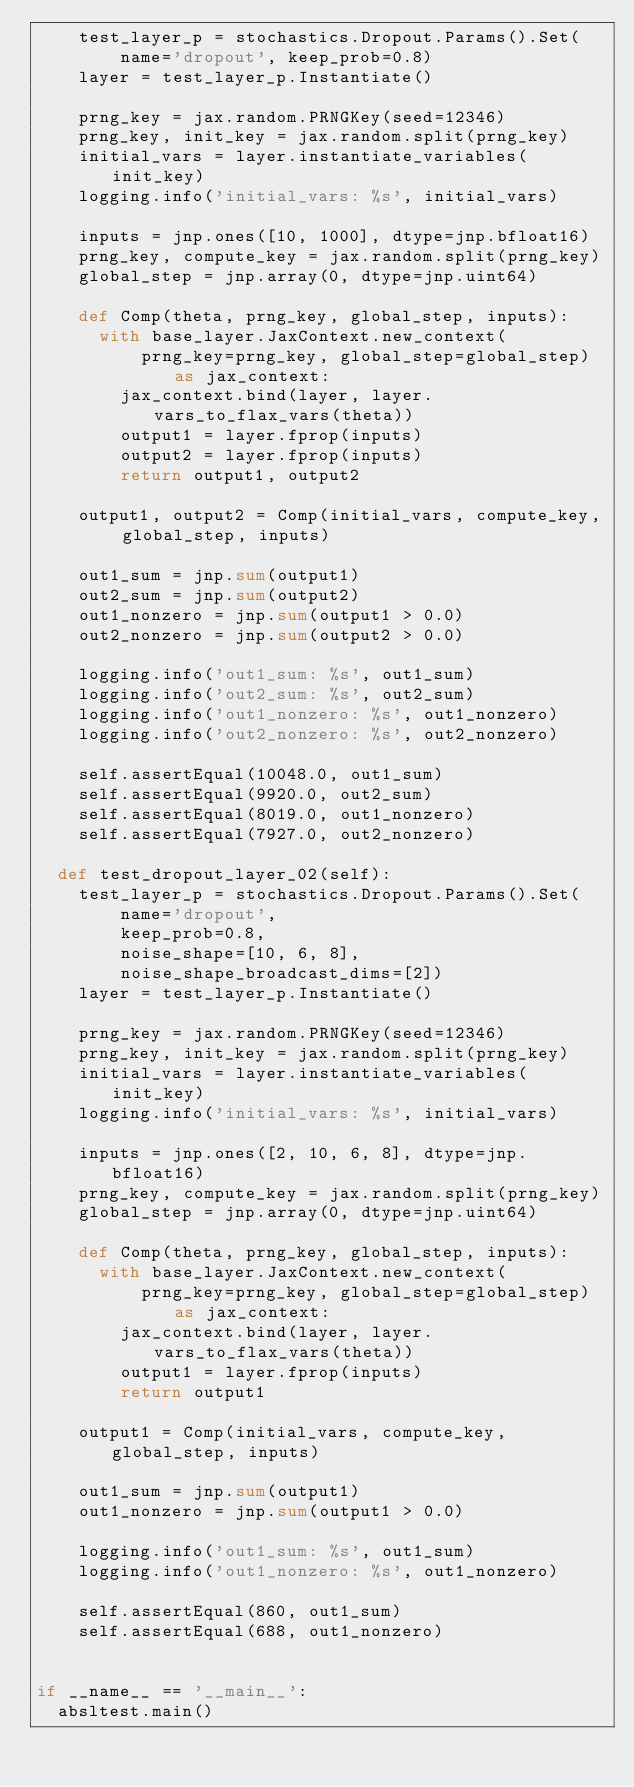Convert code to text. <code><loc_0><loc_0><loc_500><loc_500><_Python_>    test_layer_p = stochastics.Dropout.Params().Set(
        name='dropout', keep_prob=0.8)
    layer = test_layer_p.Instantiate()

    prng_key = jax.random.PRNGKey(seed=12346)
    prng_key, init_key = jax.random.split(prng_key)
    initial_vars = layer.instantiate_variables(init_key)
    logging.info('initial_vars: %s', initial_vars)

    inputs = jnp.ones([10, 1000], dtype=jnp.bfloat16)
    prng_key, compute_key = jax.random.split(prng_key)
    global_step = jnp.array(0, dtype=jnp.uint64)

    def Comp(theta, prng_key, global_step, inputs):
      with base_layer.JaxContext.new_context(
          prng_key=prng_key, global_step=global_step) as jax_context:
        jax_context.bind(layer, layer.vars_to_flax_vars(theta))
        output1 = layer.fprop(inputs)
        output2 = layer.fprop(inputs)
        return output1, output2

    output1, output2 = Comp(initial_vars, compute_key, global_step, inputs)

    out1_sum = jnp.sum(output1)
    out2_sum = jnp.sum(output2)
    out1_nonzero = jnp.sum(output1 > 0.0)
    out2_nonzero = jnp.sum(output2 > 0.0)

    logging.info('out1_sum: %s', out1_sum)
    logging.info('out2_sum: %s', out2_sum)
    logging.info('out1_nonzero: %s', out1_nonzero)
    logging.info('out2_nonzero: %s', out2_nonzero)

    self.assertEqual(10048.0, out1_sum)
    self.assertEqual(9920.0, out2_sum)
    self.assertEqual(8019.0, out1_nonzero)
    self.assertEqual(7927.0, out2_nonzero)

  def test_dropout_layer_02(self):
    test_layer_p = stochastics.Dropout.Params().Set(
        name='dropout',
        keep_prob=0.8,
        noise_shape=[10, 6, 8],
        noise_shape_broadcast_dims=[2])
    layer = test_layer_p.Instantiate()

    prng_key = jax.random.PRNGKey(seed=12346)
    prng_key, init_key = jax.random.split(prng_key)
    initial_vars = layer.instantiate_variables(init_key)
    logging.info('initial_vars: %s', initial_vars)

    inputs = jnp.ones([2, 10, 6, 8], dtype=jnp.bfloat16)
    prng_key, compute_key = jax.random.split(prng_key)
    global_step = jnp.array(0, dtype=jnp.uint64)

    def Comp(theta, prng_key, global_step, inputs):
      with base_layer.JaxContext.new_context(
          prng_key=prng_key, global_step=global_step) as jax_context:
        jax_context.bind(layer, layer.vars_to_flax_vars(theta))
        output1 = layer.fprop(inputs)
        return output1

    output1 = Comp(initial_vars, compute_key, global_step, inputs)

    out1_sum = jnp.sum(output1)
    out1_nonzero = jnp.sum(output1 > 0.0)

    logging.info('out1_sum: %s', out1_sum)
    logging.info('out1_nonzero: %s', out1_nonzero)

    self.assertEqual(860, out1_sum)
    self.assertEqual(688, out1_nonzero)


if __name__ == '__main__':
  absltest.main()
</code> 